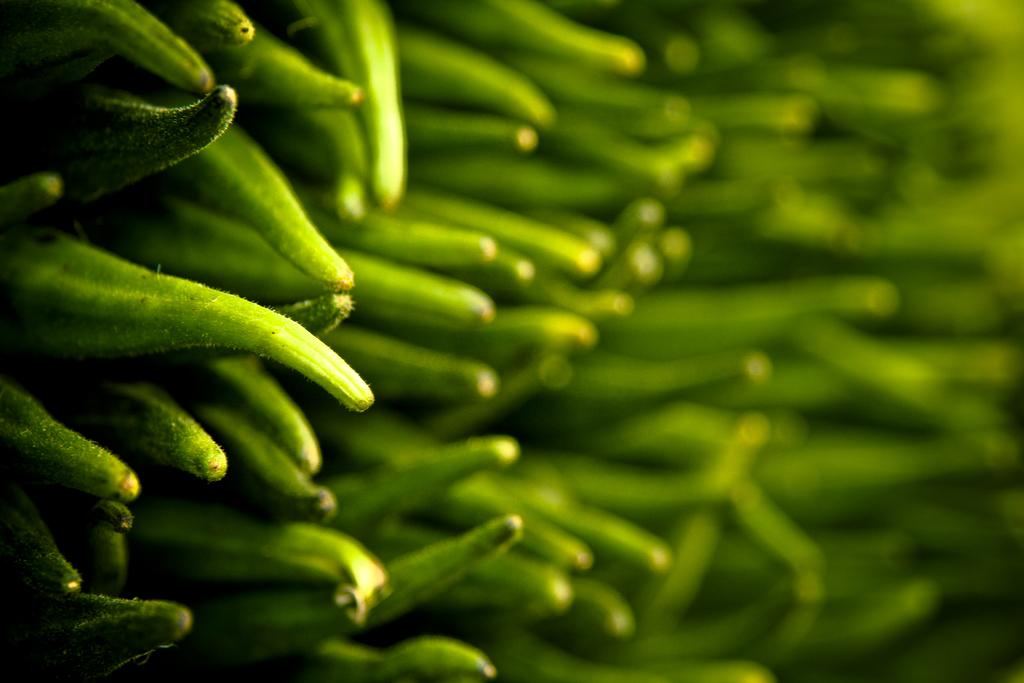What type of vegetable is present in the image? There is okra in the image. How many snakes are slithering around the okra in the image? There are no snakes present in the image; it only features okra. What type of bubble can be seen surrounding the okra in the image? There is no bubble present in the image; it only features okra. 